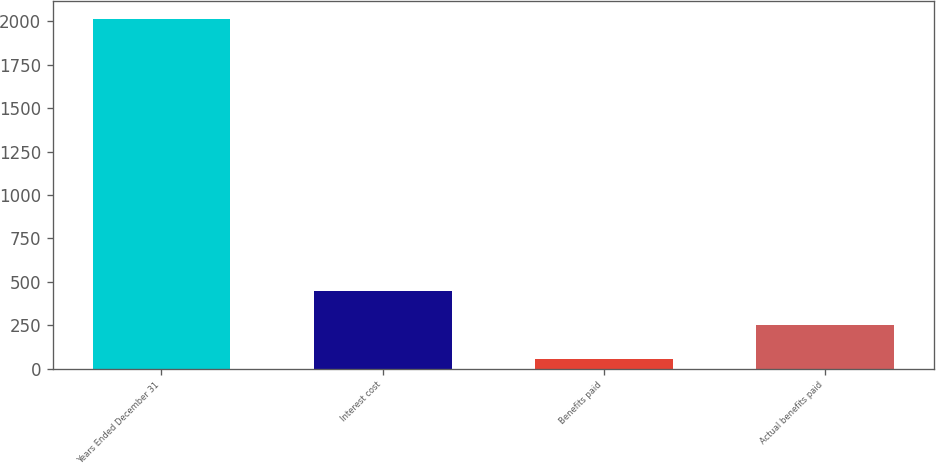<chart> <loc_0><loc_0><loc_500><loc_500><bar_chart><fcel>Years Ended December 31<fcel>Interest cost<fcel>Benefits paid<fcel>Actual benefits paid<nl><fcel>2015<fcel>448.6<fcel>57<fcel>252.8<nl></chart> 